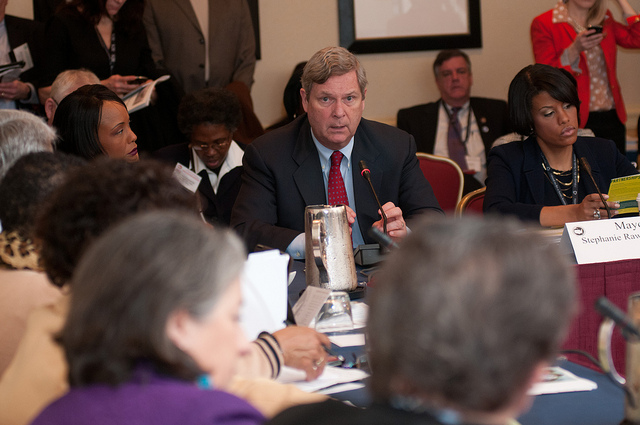Identify the text displayed in this image. May Stephanie 